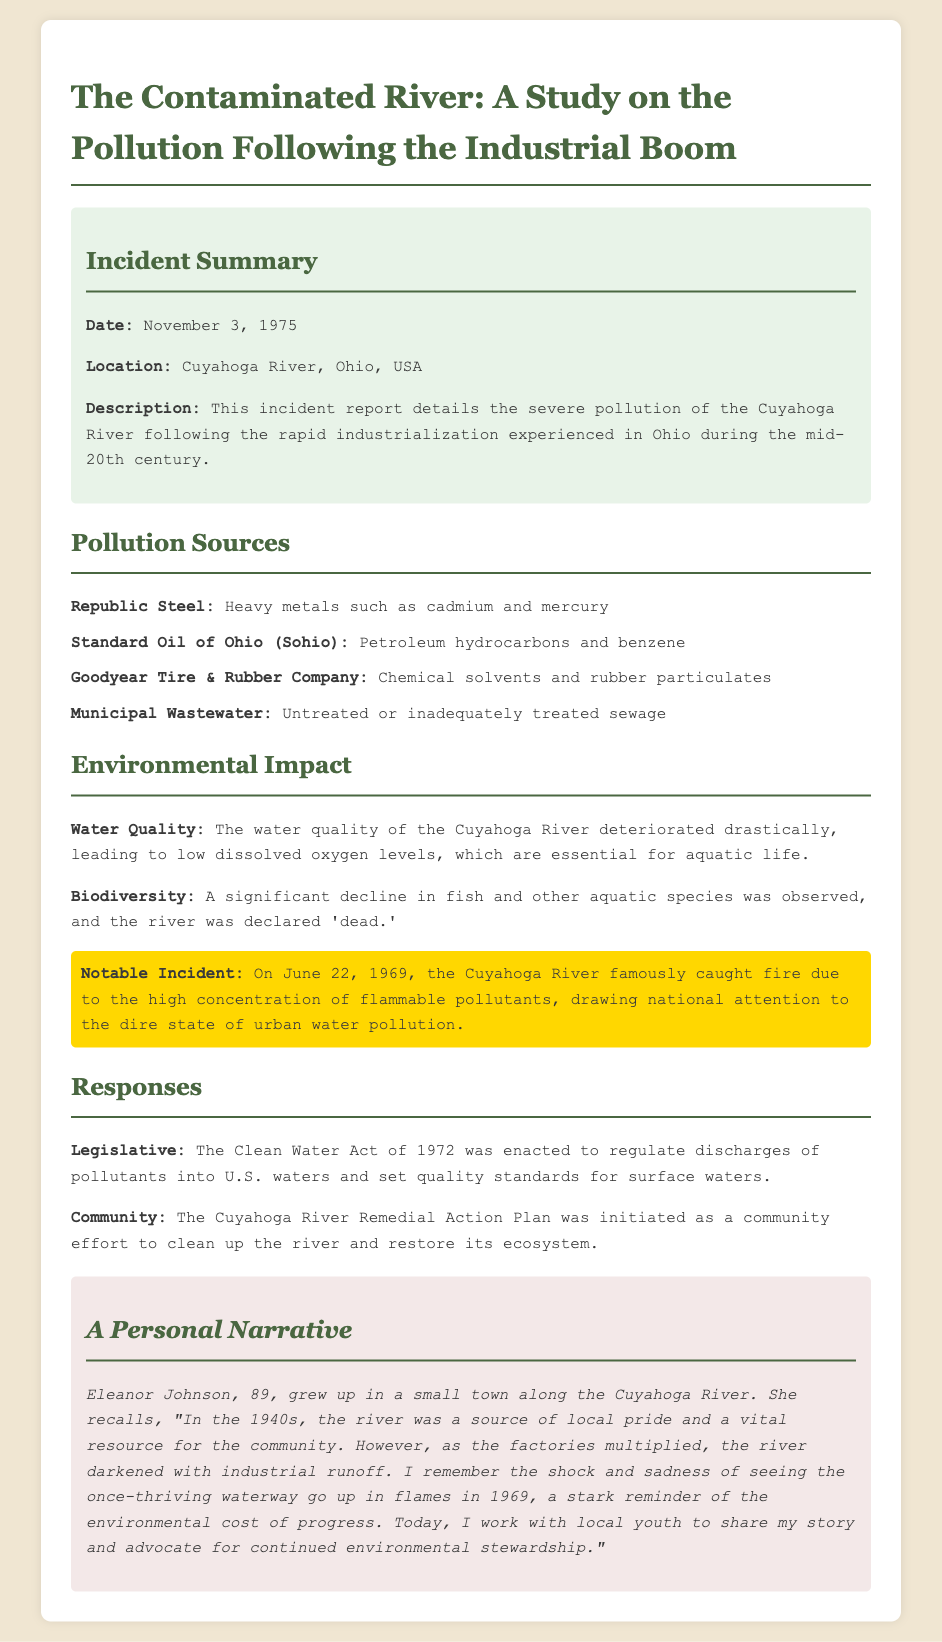what is the date of the incident? The incident date is explicitly mentioned in the "Incident Summary" section of the document.
Answer: November 3, 1975 where did the pollution incident occur? The location of the incident is specified as well in the "Incident Summary" section.
Answer: Cuyahoga River, Ohio, USA which company is associated with cadmium and mercury? The document lists companies and their associated pollutants under the "Pollution Sources" section.
Answer: Republic Steel what notable event happened on June 22, 1969? The document describes a significant occurrence related to the pollution in a highlighted section under "Environmental Impact."
Answer: The river famously caught fire what act was enacted in response to the pollution? The legislative response to the pollution is detailed in the "Responses" section of the document.
Answer: The Clean Water Act of 1972 who is the personal narrative attributed to? The section titled "A Personal Narrative" identifies the narrator of the story.
Answer: Eleanor Johnson what was the main environmental impact mentioned? The water quality and its deterioration are highlighted in the "Environmental Impact" section.
Answer: Low dissolved oxygen levels what community initiative was started to address the pollution? The document outlines community efforts under the "Responses" section.
Answer: Cuyahoga River Remedial Action Plan 